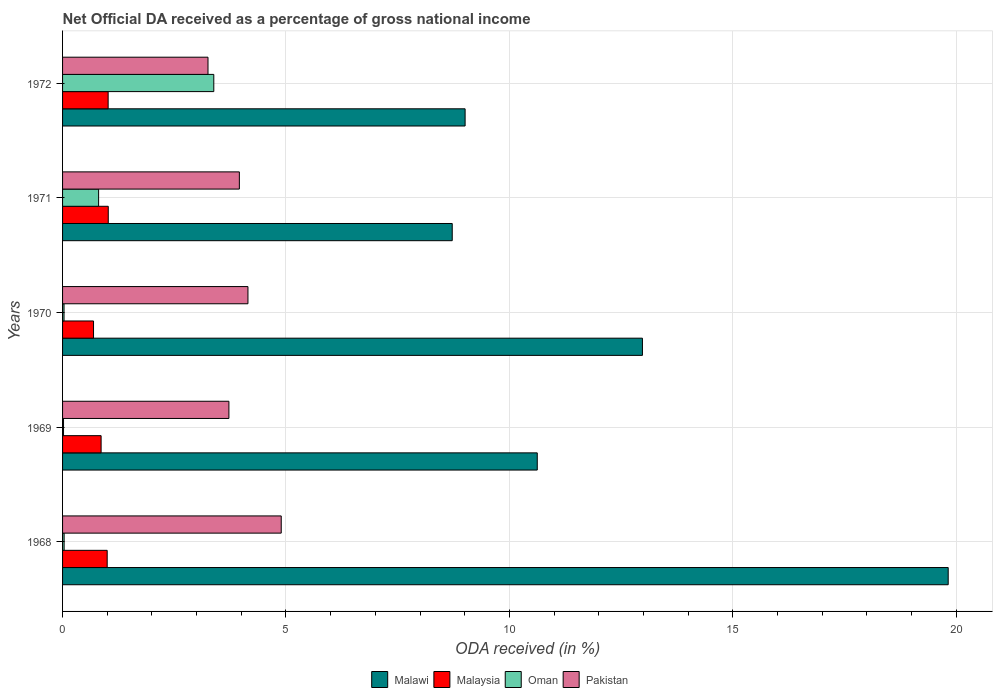How many groups of bars are there?
Ensure brevity in your answer.  5. Are the number of bars per tick equal to the number of legend labels?
Make the answer very short. Yes. What is the net official DA received in Malaysia in 1971?
Ensure brevity in your answer.  1.02. Across all years, what is the maximum net official DA received in Pakistan?
Ensure brevity in your answer.  4.89. Across all years, what is the minimum net official DA received in Pakistan?
Ensure brevity in your answer.  3.25. In which year was the net official DA received in Pakistan maximum?
Provide a short and direct response. 1968. What is the total net official DA received in Pakistan in the graph?
Make the answer very short. 19.98. What is the difference between the net official DA received in Oman in 1968 and that in 1972?
Provide a succinct answer. -3.35. What is the difference between the net official DA received in Oman in 1971 and the net official DA received in Malaysia in 1968?
Your answer should be compact. -0.19. What is the average net official DA received in Malawi per year?
Your response must be concise. 12.23. In the year 1969, what is the difference between the net official DA received in Malaysia and net official DA received in Malawi?
Offer a terse response. -9.76. In how many years, is the net official DA received in Malaysia greater than 7 %?
Provide a short and direct response. 0. What is the ratio of the net official DA received in Malaysia in 1971 to that in 1972?
Your answer should be compact. 1. What is the difference between the highest and the second highest net official DA received in Malawi?
Ensure brevity in your answer.  6.84. What is the difference between the highest and the lowest net official DA received in Oman?
Give a very brief answer. 3.36. In how many years, is the net official DA received in Malaysia greater than the average net official DA received in Malaysia taken over all years?
Make the answer very short. 3. Is the sum of the net official DA received in Oman in 1968 and 1970 greater than the maximum net official DA received in Malawi across all years?
Your answer should be very brief. No. Is it the case that in every year, the sum of the net official DA received in Oman and net official DA received in Malawi is greater than the sum of net official DA received in Pakistan and net official DA received in Malaysia?
Make the answer very short. No. What does the 4th bar from the top in 1972 represents?
Ensure brevity in your answer.  Malawi. What does the 1st bar from the bottom in 1968 represents?
Offer a terse response. Malawi. Is it the case that in every year, the sum of the net official DA received in Oman and net official DA received in Malawi is greater than the net official DA received in Pakistan?
Offer a very short reply. Yes. What is the difference between two consecutive major ticks on the X-axis?
Offer a very short reply. 5. Are the values on the major ticks of X-axis written in scientific E-notation?
Your answer should be very brief. No. Does the graph contain any zero values?
Provide a succinct answer. No. How are the legend labels stacked?
Your answer should be very brief. Horizontal. What is the title of the graph?
Offer a terse response. Net Official DA received as a percentage of gross national income. Does "Singapore" appear as one of the legend labels in the graph?
Your answer should be compact. No. What is the label or title of the X-axis?
Give a very brief answer. ODA received (in %). What is the ODA received (in %) in Malawi in 1968?
Your answer should be compact. 19.82. What is the ODA received (in %) in Malaysia in 1968?
Ensure brevity in your answer.  1. What is the ODA received (in %) in Oman in 1968?
Provide a short and direct response. 0.04. What is the ODA received (in %) in Pakistan in 1968?
Give a very brief answer. 4.89. What is the ODA received (in %) of Malawi in 1969?
Your answer should be very brief. 10.62. What is the ODA received (in %) in Malaysia in 1969?
Keep it short and to the point. 0.86. What is the ODA received (in %) in Oman in 1969?
Your response must be concise. 0.02. What is the ODA received (in %) of Pakistan in 1969?
Give a very brief answer. 3.72. What is the ODA received (in %) in Malawi in 1970?
Offer a very short reply. 12.98. What is the ODA received (in %) of Malaysia in 1970?
Your answer should be very brief. 0.69. What is the ODA received (in %) in Oman in 1970?
Ensure brevity in your answer.  0.03. What is the ODA received (in %) in Pakistan in 1970?
Provide a short and direct response. 4.15. What is the ODA received (in %) in Malawi in 1971?
Provide a short and direct response. 8.72. What is the ODA received (in %) of Malaysia in 1971?
Your answer should be very brief. 1.02. What is the ODA received (in %) of Oman in 1971?
Provide a short and direct response. 0.81. What is the ODA received (in %) in Pakistan in 1971?
Provide a short and direct response. 3.96. What is the ODA received (in %) of Malawi in 1972?
Your response must be concise. 9.01. What is the ODA received (in %) in Malaysia in 1972?
Provide a short and direct response. 1.02. What is the ODA received (in %) in Oman in 1972?
Ensure brevity in your answer.  3.38. What is the ODA received (in %) of Pakistan in 1972?
Offer a terse response. 3.25. Across all years, what is the maximum ODA received (in %) of Malawi?
Give a very brief answer. 19.82. Across all years, what is the maximum ODA received (in %) of Malaysia?
Keep it short and to the point. 1.02. Across all years, what is the maximum ODA received (in %) of Oman?
Give a very brief answer. 3.38. Across all years, what is the maximum ODA received (in %) in Pakistan?
Your response must be concise. 4.89. Across all years, what is the minimum ODA received (in %) of Malawi?
Provide a succinct answer. 8.72. Across all years, what is the minimum ODA received (in %) of Malaysia?
Offer a terse response. 0.69. Across all years, what is the minimum ODA received (in %) in Oman?
Offer a terse response. 0.02. Across all years, what is the minimum ODA received (in %) in Pakistan?
Provide a short and direct response. 3.25. What is the total ODA received (in %) of Malawi in the graph?
Offer a very short reply. 61.16. What is the total ODA received (in %) in Malaysia in the graph?
Give a very brief answer. 4.6. What is the total ODA received (in %) in Oman in the graph?
Your answer should be very brief. 4.28. What is the total ODA received (in %) of Pakistan in the graph?
Your answer should be compact. 19.98. What is the difference between the ODA received (in %) in Malawi in 1968 and that in 1969?
Give a very brief answer. 9.2. What is the difference between the ODA received (in %) of Malaysia in 1968 and that in 1969?
Provide a succinct answer. 0.14. What is the difference between the ODA received (in %) of Oman in 1968 and that in 1969?
Give a very brief answer. 0.01. What is the difference between the ODA received (in %) in Pakistan in 1968 and that in 1969?
Give a very brief answer. 1.17. What is the difference between the ODA received (in %) in Malawi in 1968 and that in 1970?
Ensure brevity in your answer.  6.84. What is the difference between the ODA received (in %) in Malaysia in 1968 and that in 1970?
Your answer should be compact. 0.31. What is the difference between the ODA received (in %) in Oman in 1968 and that in 1970?
Keep it short and to the point. 0. What is the difference between the ODA received (in %) in Pakistan in 1968 and that in 1970?
Provide a succinct answer. 0.74. What is the difference between the ODA received (in %) in Malawi in 1968 and that in 1971?
Give a very brief answer. 11.1. What is the difference between the ODA received (in %) of Malaysia in 1968 and that in 1971?
Your answer should be very brief. -0.02. What is the difference between the ODA received (in %) in Oman in 1968 and that in 1971?
Your answer should be compact. -0.77. What is the difference between the ODA received (in %) of Pakistan in 1968 and that in 1971?
Your response must be concise. 0.94. What is the difference between the ODA received (in %) of Malawi in 1968 and that in 1972?
Make the answer very short. 10.81. What is the difference between the ODA received (in %) in Malaysia in 1968 and that in 1972?
Give a very brief answer. -0.02. What is the difference between the ODA received (in %) in Oman in 1968 and that in 1972?
Offer a very short reply. -3.35. What is the difference between the ODA received (in %) in Pakistan in 1968 and that in 1972?
Make the answer very short. 1.64. What is the difference between the ODA received (in %) in Malawi in 1969 and that in 1970?
Make the answer very short. -2.35. What is the difference between the ODA received (in %) in Malaysia in 1969 and that in 1970?
Keep it short and to the point. 0.17. What is the difference between the ODA received (in %) in Oman in 1969 and that in 1970?
Your response must be concise. -0.01. What is the difference between the ODA received (in %) of Pakistan in 1969 and that in 1970?
Offer a terse response. -0.43. What is the difference between the ODA received (in %) of Malawi in 1969 and that in 1971?
Give a very brief answer. 1.9. What is the difference between the ODA received (in %) of Malaysia in 1969 and that in 1971?
Ensure brevity in your answer.  -0.16. What is the difference between the ODA received (in %) in Oman in 1969 and that in 1971?
Offer a terse response. -0.78. What is the difference between the ODA received (in %) in Pakistan in 1969 and that in 1971?
Provide a short and direct response. -0.23. What is the difference between the ODA received (in %) in Malawi in 1969 and that in 1972?
Provide a short and direct response. 1.61. What is the difference between the ODA received (in %) of Malaysia in 1969 and that in 1972?
Give a very brief answer. -0.16. What is the difference between the ODA received (in %) of Oman in 1969 and that in 1972?
Your answer should be compact. -3.36. What is the difference between the ODA received (in %) in Pakistan in 1969 and that in 1972?
Your answer should be very brief. 0.47. What is the difference between the ODA received (in %) of Malawi in 1970 and that in 1971?
Offer a terse response. 4.26. What is the difference between the ODA received (in %) of Malaysia in 1970 and that in 1971?
Offer a very short reply. -0.33. What is the difference between the ODA received (in %) in Oman in 1970 and that in 1971?
Your answer should be compact. -0.77. What is the difference between the ODA received (in %) in Pakistan in 1970 and that in 1971?
Your answer should be very brief. 0.19. What is the difference between the ODA received (in %) in Malawi in 1970 and that in 1972?
Offer a very short reply. 3.97. What is the difference between the ODA received (in %) of Malaysia in 1970 and that in 1972?
Your answer should be compact. -0.33. What is the difference between the ODA received (in %) of Oman in 1970 and that in 1972?
Provide a succinct answer. -3.35. What is the difference between the ODA received (in %) in Pakistan in 1970 and that in 1972?
Keep it short and to the point. 0.89. What is the difference between the ODA received (in %) of Malawi in 1971 and that in 1972?
Your answer should be very brief. -0.29. What is the difference between the ODA received (in %) in Malaysia in 1971 and that in 1972?
Ensure brevity in your answer.  0. What is the difference between the ODA received (in %) in Oman in 1971 and that in 1972?
Your response must be concise. -2.58. What is the difference between the ODA received (in %) in Pakistan in 1971 and that in 1972?
Keep it short and to the point. 0.7. What is the difference between the ODA received (in %) of Malawi in 1968 and the ODA received (in %) of Malaysia in 1969?
Provide a short and direct response. 18.96. What is the difference between the ODA received (in %) in Malawi in 1968 and the ODA received (in %) in Oman in 1969?
Your answer should be very brief. 19.8. What is the difference between the ODA received (in %) of Malawi in 1968 and the ODA received (in %) of Pakistan in 1969?
Provide a short and direct response. 16.1. What is the difference between the ODA received (in %) of Malaysia in 1968 and the ODA received (in %) of Oman in 1969?
Ensure brevity in your answer.  0.98. What is the difference between the ODA received (in %) of Malaysia in 1968 and the ODA received (in %) of Pakistan in 1969?
Offer a very short reply. -2.72. What is the difference between the ODA received (in %) in Oman in 1968 and the ODA received (in %) in Pakistan in 1969?
Keep it short and to the point. -3.69. What is the difference between the ODA received (in %) of Malawi in 1968 and the ODA received (in %) of Malaysia in 1970?
Keep it short and to the point. 19.13. What is the difference between the ODA received (in %) in Malawi in 1968 and the ODA received (in %) in Oman in 1970?
Give a very brief answer. 19.79. What is the difference between the ODA received (in %) of Malawi in 1968 and the ODA received (in %) of Pakistan in 1970?
Keep it short and to the point. 15.67. What is the difference between the ODA received (in %) of Malaysia in 1968 and the ODA received (in %) of Oman in 1970?
Offer a very short reply. 0.97. What is the difference between the ODA received (in %) in Malaysia in 1968 and the ODA received (in %) in Pakistan in 1970?
Your answer should be compact. -3.15. What is the difference between the ODA received (in %) in Oman in 1968 and the ODA received (in %) in Pakistan in 1970?
Make the answer very short. -4.11. What is the difference between the ODA received (in %) of Malawi in 1968 and the ODA received (in %) of Malaysia in 1971?
Make the answer very short. 18.8. What is the difference between the ODA received (in %) in Malawi in 1968 and the ODA received (in %) in Oman in 1971?
Keep it short and to the point. 19.02. What is the difference between the ODA received (in %) of Malawi in 1968 and the ODA received (in %) of Pakistan in 1971?
Your answer should be very brief. 15.86. What is the difference between the ODA received (in %) in Malaysia in 1968 and the ODA received (in %) in Oman in 1971?
Give a very brief answer. 0.19. What is the difference between the ODA received (in %) of Malaysia in 1968 and the ODA received (in %) of Pakistan in 1971?
Provide a succinct answer. -2.96. What is the difference between the ODA received (in %) of Oman in 1968 and the ODA received (in %) of Pakistan in 1971?
Provide a short and direct response. -3.92. What is the difference between the ODA received (in %) in Malawi in 1968 and the ODA received (in %) in Malaysia in 1972?
Your answer should be very brief. 18.8. What is the difference between the ODA received (in %) in Malawi in 1968 and the ODA received (in %) in Oman in 1972?
Offer a very short reply. 16.44. What is the difference between the ODA received (in %) in Malawi in 1968 and the ODA received (in %) in Pakistan in 1972?
Offer a very short reply. 16.57. What is the difference between the ODA received (in %) of Malaysia in 1968 and the ODA received (in %) of Oman in 1972?
Your answer should be compact. -2.39. What is the difference between the ODA received (in %) of Malaysia in 1968 and the ODA received (in %) of Pakistan in 1972?
Ensure brevity in your answer.  -2.26. What is the difference between the ODA received (in %) of Oman in 1968 and the ODA received (in %) of Pakistan in 1972?
Your answer should be compact. -3.22. What is the difference between the ODA received (in %) of Malawi in 1969 and the ODA received (in %) of Malaysia in 1970?
Offer a terse response. 9.93. What is the difference between the ODA received (in %) of Malawi in 1969 and the ODA received (in %) of Oman in 1970?
Keep it short and to the point. 10.59. What is the difference between the ODA received (in %) in Malawi in 1969 and the ODA received (in %) in Pakistan in 1970?
Your answer should be very brief. 6.48. What is the difference between the ODA received (in %) of Malaysia in 1969 and the ODA received (in %) of Oman in 1970?
Provide a short and direct response. 0.83. What is the difference between the ODA received (in %) in Malaysia in 1969 and the ODA received (in %) in Pakistan in 1970?
Your answer should be very brief. -3.29. What is the difference between the ODA received (in %) in Oman in 1969 and the ODA received (in %) in Pakistan in 1970?
Offer a terse response. -4.13. What is the difference between the ODA received (in %) of Malawi in 1969 and the ODA received (in %) of Malaysia in 1971?
Provide a short and direct response. 9.6. What is the difference between the ODA received (in %) in Malawi in 1969 and the ODA received (in %) in Oman in 1971?
Provide a succinct answer. 9.82. What is the difference between the ODA received (in %) of Malawi in 1969 and the ODA received (in %) of Pakistan in 1971?
Keep it short and to the point. 6.67. What is the difference between the ODA received (in %) of Malaysia in 1969 and the ODA received (in %) of Oman in 1971?
Keep it short and to the point. 0.06. What is the difference between the ODA received (in %) in Malaysia in 1969 and the ODA received (in %) in Pakistan in 1971?
Your answer should be very brief. -3.09. What is the difference between the ODA received (in %) in Oman in 1969 and the ODA received (in %) in Pakistan in 1971?
Provide a succinct answer. -3.94. What is the difference between the ODA received (in %) in Malawi in 1969 and the ODA received (in %) in Malaysia in 1972?
Give a very brief answer. 9.6. What is the difference between the ODA received (in %) in Malawi in 1969 and the ODA received (in %) in Oman in 1972?
Give a very brief answer. 7.24. What is the difference between the ODA received (in %) in Malawi in 1969 and the ODA received (in %) in Pakistan in 1972?
Provide a succinct answer. 7.37. What is the difference between the ODA received (in %) in Malaysia in 1969 and the ODA received (in %) in Oman in 1972?
Offer a terse response. -2.52. What is the difference between the ODA received (in %) in Malaysia in 1969 and the ODA received (in %) in Pakistan in 1972?
Give a very brief answer. -2.39. What is the difference between the ODA received (in %) in Oman in 1969 and the ODA received (in %) in Pakistan in 1972?
Your answer should be compact. -3.23. What is the difference between the ODA received (in %) of Malawi in 1970 and the ODA received (in %) of Malaysia in 1971?
Your answer should be very brief. 11.96. What is the difference between the ODA received (in %) of Malawi in 1970 and the ODA received (in %) of Oman in 1971?
Your answer should be very brief. 12.17. What is the difference between the ODA received (in %) in Malawi in 1970 and the ODA received (in %) in Pakistan in 1971?
Keep it short and to the point. 9.02. What is the difference between the ODA received (in %) of Malaysia in 1970 and the ODA received (in %) of Oman in 1971?
Provide a short and direct response. -0.11. What is the difference between the ODA received (in %) of Malaysia in 1970 and the ODA received (in %) of Pakistan in 1971?
Make the answer very short. -3.26. What is the difference between the ODA received (in %) in Oman in 1970 and the ODA received (in %) in Pakistan in 1971?
Keep it short and to the point. -3.92. What is the difference between the ODA received (in %) of Malawi in 1970 and the ODA received (in %) of Malaysia in 1972?
Provide a short and direct response. 11.96. What is the difference between the ODA received (in %) of Malawi in 1970 and the ODA received (in %) of Oman in 1972?
Your answer should be compact. 9.59. What is the difference between the ODA received (in %) in Malawi in 1970 and the ODA received (in %) in Pakistan in 1972?
Make the answer very short. 9.72. What is the difference between the ODA received (in %) of Malaysia in 1970 and the ODA received (in %) of Oman in 1972?
Keep it short and to the point. -2.69. What is the difference between the ODA received (in %) in Malaysia in 1970 and the ODA received (in %) in Pakistan in 1972?
Give a very brief answer. -2.56. What is the difference between the ODA received (in %) of Oman in 1970 and the ODA received (in %) of Pakistan in 1972?
Ensure brevity in your answer.  -3.22. What is the difference between the ODA received (in %) of Malawi in 1971 and the ODA received (in %) of Malaysia in 1972?
Provide a succinct answer. 7.7. What is the difference between the ODA received (in %) of Malawi in 1971 and the ODA received (in %) of Oman in 1972?
Offer a terse response. 5.34. What is the difference between the ODA received (in %) in Malawi in 1971 and the ODA received (in %) in Pakistan in 1972?
Your response must be concise. 5.47. What is the difference between the ODA received (in %) of Malaysia in 1971 and the ODA received (in %) of Oman in 1972?
Offer a very short reply. -2.36. What is the difference between the ODA received (in %) of Malaysia in 1971 and the ODA received (in %) of Pakistan in 1972?
Ensure brevity in your answer.  -2.23. What is the difference between the ODA received (in %) in Oman in 1971 and the ODA received (in %) in Pakistan in 1972?
Provide a short and direct response. -2.45. What is the average ODA received (in %) of Malawi per year?
Ensure brevity in your answer.  12.23. What is the average ODA received (in %) of Malaysia per year?
Provide a succinct answer. 0.92. What is the average ODA received (in %) of Oman per year?
Offer a very short reply. 0.86. What is the average ODA received (in %) in Pakistan per year?
Give a very brief answer. 4. In the year 1968, what is the difference between the ODA received (in %) of Malawi and ODA received (in %) of Malaysia?
Offer a very short reply. 18.82. In the year 1968, what is the difference between the ODA received (in %) of Malawi and ODA received (in %) of Oman?
Your answer should be compact. 19.79. In the year 1968, what is the difference between the ODA received (in %) in Malawi and ODA received (in %) in Pakistan?
Offer a very short reply. 14.93. In the year 1968, what is the difference between the ODA received (in %) in Malaysia and ODA received (in %) in Oman?
Your answer should be compact. 0.96. In the year 1968, what is the difference between the ODA received (in %) of Malaysia and ODA received (in %) of Pakistan?
Your answer should be very brief. -3.9. In the year 1968, what is the difference between the ODA received (in %) in Oman and ODA received (in %) in Pakistan?
Keep it short and to the point. -4.86. In the year 1969, what is the difference between the ODA received (in %) in Malawi and ODA received (in %) in Malaysia?
Your answer should be very brief. 9.76. In the year 1969, what is the difference between the ODA received (in %) in Malawi and ODA received (in %) in Oman?
Give a very brief answer. 10.6. In the year 1969, what is the difference between the ODA received (in %) in Malawi and ODA received (in %) in Pakistan?
Offer a terse response. 6.9. In the year 1969, what is the difference between the ODA received (in %) in Malaysia and ODA received (in %) in Oman?
Offer a terse response. 0.84. In the year 1969, what is the difference between the ODA received (in %) of Malaysia and ODA received (in %) of Pakistan?
Keep it short and to the point. -2.86. In the year 1969, what is the difference between the ODA received (in %) of Oman and ODA received (in %) of Pakistan?
Provide a short and direct response. -3.7. In the year 1970, what is the difference between the ODA received (in %) of Malawi and ODA received (in %) of Malaysia?
Ensure brevity in your answer.  12.29. In the year 1970, what is the difference between the ODA received (in %) of Malawi and ODA received (in %) of Oman?
Provide a short and direct response. 12.95. In the year 1970, what is the difference between the ODA received (in %) in Malawi and ODA received (in %) in Pakistan?
Offer a very short reply. 8.83. In the year 1970, what is the difference between the ODA received (in %) in Malaysia and ODA received (in %) in Oman?
Ensure brevity in your answer.  0.66. In the year 1970, what is the difference between the ODA received (in %) of Malaysia and ODA received (in %) of Pakistan?
Your answer should be compact. -3.46. In the year 1970, what is the difference between the ODA received (in %) in Oman and ODA received (in %) in Pakistan?
Offer a very short reply. -4.12. In the year 1971, what is the difference between the ODA received (in %) in Malawi and ODA received (in %) in Malaysia?
Provide a short and direct response. 7.7. In the year 1971, what is the difference between the ODA received (in %) of Malawi and ODA received (in %) of Oman?
Keep it short and to the point. 7.91. In the year 1971, what is the difference between the ODA received (in %) in Malawi and ODA received (in %) in Pakistan?
Keep it short and to the point. 4.76. In the year 1971, what is the difference between the ODA received (in %) of Malaysia and ODA received (in %) of Oman?
Give a very brief answer. 0.22. In the year 1971, what is the difference between the ODA received (in %) in Malaysia and ODA received (in %) in Pakistan?
Keep it short and to the point. -2.93. In the year 1971, what is the difference between the ODA received (in %) of Oman and ODA received (in %) of Pakistan?
Ensure brevity in your answer.  -3.15. In the year 1972, what is the difference between the ODA received (in %) in Malawi and ODA received (in %) in Malaysia?
Provide a succinct answer. 7.99. In the year 1972, what is the difference between the ODA received (in %) in Malawi and ODA received (in %) in Oman?
Give a very brief answer. 5.62. In the year 1972, what is the difference between the ODA received (in %) of Malawi and ODA received (in %) of Pakistan?
Give a very brief answer. 5.75. In the year 1972, what is the difference between the ODA received (in %) of Malaysia and ODA received (in %) of Oman?
Ensure brevity in your answer.  -2.36. In the year 1972, what is the difference between the ODA received (in %) in Malaysia and ODA received (in %) in Pakistan?
Offer a very short reply. -2.23. In the year 1972, what is the difference between the ODA received (in %) of Oman and ODA received (in %) of Pakistan?
Ensure brevity in your answer.  0.13. What is the ratio of the ODA received (in %) of Malawi in 1968 to that in 1969?
Make the answer very short. 1.87. What is the ratio of the ODA received (in %) of Malaysia in 1968 to that in 1969?
Your answer should be compact. 1.16. What is the ratio of the ODA received (in %) of Oman in 1968 to that in 1969?
Give a very brief answer. 1.61. What is the ratio of the ODA received (in %) of Pakistan in 1968 to that in 1969?
Your answer should be compact. 1.31. What is the ratio of the ODA received (in %) in Malawi in 1968 to that in 1970?
Make the answer very short. 1.53. What is the ratio of the ODA received (in %) in Malaysia in 1968 to that in 1970?
Offer a terse response. 1.44. What is the ratio of the ODA received (in %) of Oman in 1968 to that in 1970?
Provide a short and direct response. 1.06. What is the ratio of the ODA received (in %) of Pakistan in 1968 to that in 1970?
Give a very brief answer. 1.18. What is the ratio of the ODA received (in %) in Malawi in 1968 to that in 1971?
Your response must be concise. 2.27. What is the ratio of the ODA received (in %) in Malaysia in 1968 to that in 1971?
Provide a succinct answer. 0.98. What is the ratio of the ODA received (in %) of Oman in 1968 to that in 1971?
Ensure brevity in your answer.  0.04. What is the ratio of the ODA received (in %) in Pakistan in 1968 to that in 1971?
Keep it short and to the point. 1.24. What is the ratio of the ODA received (in %) of Malawi in 1968 to that in 1972?
Offer a very short reply. 2.2. What is the ratio of the ODA received (in %) in Malaysia in 1968 to that in 1972?
Make the answer very short. 0.98. What is the ratio of the ODA received (in %) in Oman in 1968 to that in 1972?
Ensure brevity in your answer.  0.01. What is the ratio of the ODA received (in %) of Pakistan in 1968 to that in 1972?
Ensure brevity in your answer.  1.5. What is the ratio of the ODA received (in %) of Malawi in 1969 to that in 1970?
Your answer should be compact. 0.82. What is the ratio of the ODA received (in %) of Malaysia in 1969 to that in 1970?
Offer a very short reply. 1.24. What is the ratio of the ODA received (in %) in Oman in 1969 to that in 1970?
Offer a terse response. 0.66. What is the ratio of the ODA received (in %) of Pakistan in 1969 to that in 1970?
Your response must be concise. 0.9. What is the ratio of the ODA received (in %) in Malawi in 1969 to that in 1971?
Ensure brevity in your answer.  1.22. What is the ratio of the ODA received (in %) in Malaysia in 1969 to that in 1971?
Make the answer very short. 0.84. What is the ratio of the ODA received (in %) in Oman in 1969 to that in 1971?
Offer a terse response. 0.03. What is the ratio of the ODA received (in %) in Pakistan in 1969 to that in 1971?
Your answer should be very brief. 0.94. What is the ratio of the ODA received (in %) of Malawi in 1969 to that in 1972?
Give a very brief answer. 1.18. What is the ratio of the ODA received (in %) of Malaysia in 1969 to that in 1972?
Provide a succinct answer. 0.85. What is the ratio of the ODA received (in %) of Oman in 1969 to that in 1972?
Provide a short and direct response. 0.01. What is the ratio of the ODA received (in %) in Pakistan in 1969 to that in 1972?
Make the answer very short. 1.14. What is the ratio of the ODA received (in %) of Malawi in 1970 to that in 1971?
Offer a very short reply. 1.49. What is the ratio of the ODA received (in %) in Malaysia in 1970 to that in 1971?
Your response must be concise. 0.68. What is the ratio of the ODA received (in %) in Oman in 1970 to that in 1971?
Provide a short and direct response. 0.04. What is the ratio of the ODA received (in %) of Pakistan in 1970 to that in 1971?
Offer a terse response. 1.05. What is the ratio of the ODA received (in %) in Malawi in 1970 to that in 1972?
Give a very brief answer. 1.44. What is the ratio of the ODA received (in %) in Malaysia in 1970 to that in 1972?
Offer a terse response. 0.68. What is the ratio of the ODA received (in %) of Oman in 1970 to that in 1972?
Keep it short and to the point. 0.01. What is the ratio of the ODA received (in %) in Pakistan in 1970 to that in 1972?
Offer a terse response. 1.27. What is the ratio of the ODA received (in %) in Malawi in 1971 to that in 1972?
Give a very brief answer. 0.97. What is the ratio of the ODA received (in %) of Oman in 1971 to that in 1972?
Make the answer very short. 0.24. What is the ratio of the ODA received (in %) of Pakistan in 1971 to that in 1972?
Provide a succinct answer. 1.22. What is the difference between the highest and the second highest ODA received (in %) of Malawi?
Your answer should be very brief. 6.84. What is the difference between the highest and the second highest ODA received (in %) in Malaysia?
Make the answer very short. 0. What is the difference between the highest and the second highest ODA received (in %) of Oman?
Ensure brevity in your answer.  2.58. What is the difference between the highest and the second highest ODA received (in %) in Pakistan?
Your answer should be compact. 0.74. What is the difference between the highest and the lowest ODA received (in %) of Malawi?
Ensure brevity in your answer.  11.1. What is the difference between the highest and the lowest ODA received (in %) in Malaysia?
Offer a terse response. 0.33. What is the difference between the highest and the lowest ODA received (in %) of Oman?
Offer a terse response. 3.36. What is the difference between the highest and the lowest ODA received (in %) in Pakistan?
Your answer should be very brief. 1.64. 